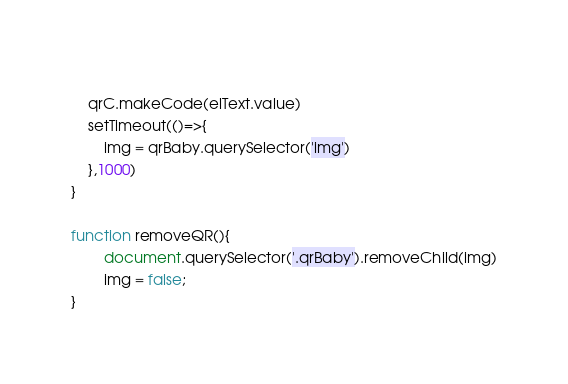Convert code to text. <code><loc_0><loc_0><loc_500><loc_500><_JavaScript_>
    
    qrC.makeCode(elText.value)
    setTimeout(()=>{
        img = qrBaby.querySelector('img')
    },1000)
}

function removeQR(){
        document.querySelector('.qrBaby').removeChild(img)
        img = false;
}</code> 